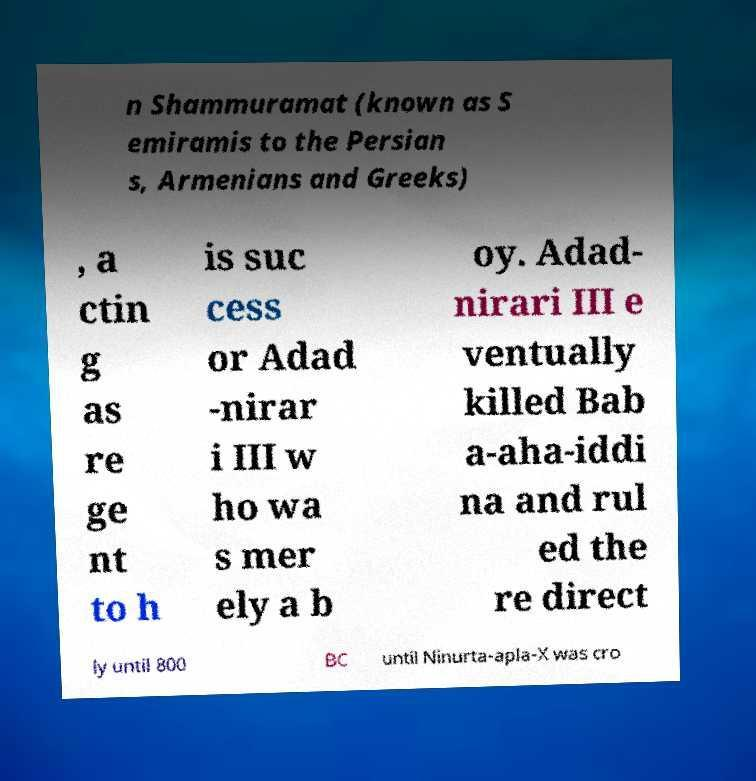Could you assist in decoding the text presented in this image and type it out clearly? n Shammuramat (known as S emiramis to the Persian s, Armenians and Greeks) , a ctin g as re ge nt to h is suc cess or Adad -nirar i III w ho wa s mer ely a b oy. Adad- nirari III e ventually killed Bab a-aha-iddi na and rul ed the re direct ly until 800 BC until Ninurta-apla-X was cro 